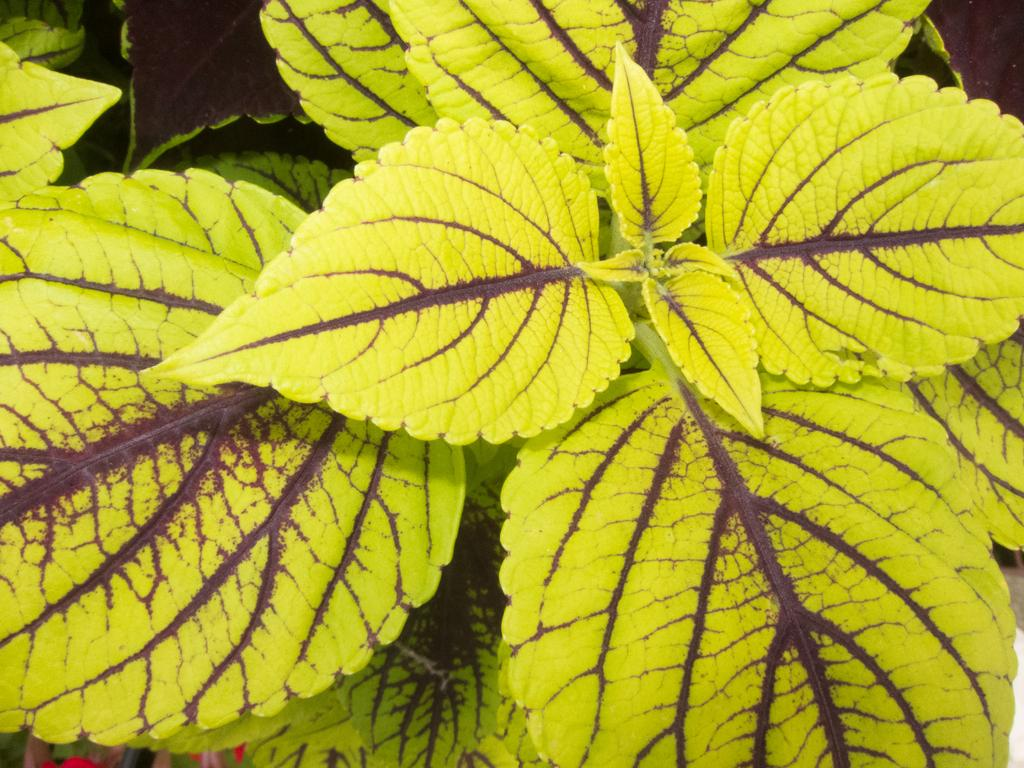What is present in the image? There is a plant in the image. What part of the plant is visible in the image? There are leaves visible in the image. What type of chin is visible on the family member in the image? There is no family member or chin present in the image; it only features a plant with leaves. 